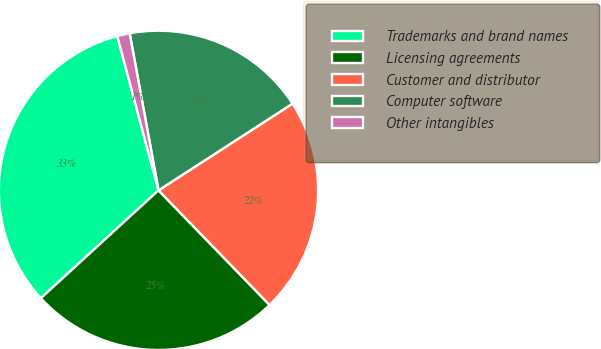Convert chart. <chart><loc_0><loc_0><loc_500><loc_500><pie_chart><fcel>Trademarks and brand names<fcel>Licensing agreements<fcel>Customer and distributor<fcel>Computer software<fcel>Other intangibles<nl><fcel>32.65%<fcel>25.44%<fcel>21.89%<fcel>18.75%<fcel>1.27%<nl></chart> 